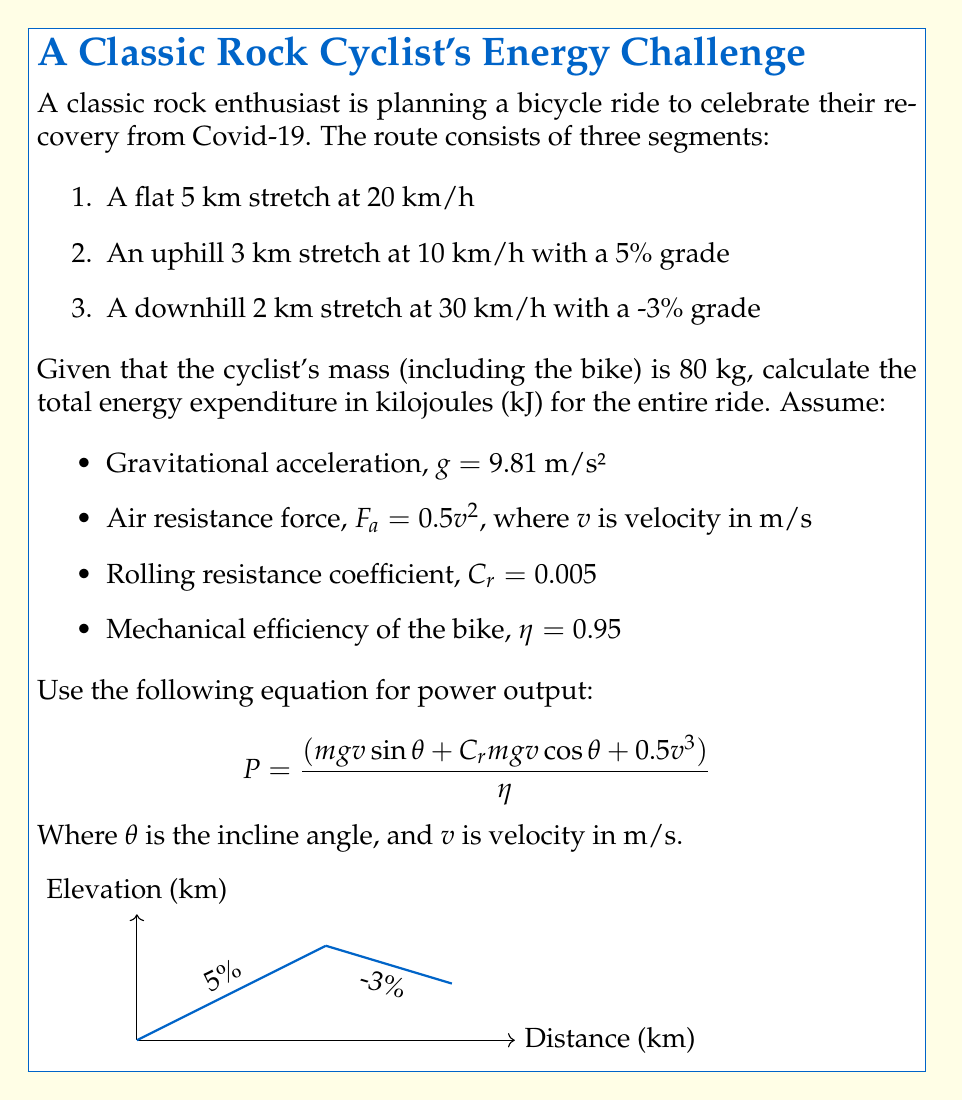Help me with this question. Let's break this down step-by-step:

1) First, we need to convert all speeds to m/s:
   20 km/h = 5.56 m/s
   10 km/h = 2.78 m/s
   30 km/h = 8.33 m/s

2) Calculate the incline angles:
   5% grade: $\theta_1 = \arctan(0.05) = 0.0499$ radians
   -3% grade: $\theta_2 = \arctan(-0.03) = -0.0300$ radians

3) Now, let's calculate the power for each segment using the given equation:

   Segment 1 (flat):
   $$P_1 = \frac{(80 \cdot 9.81 \cdot 5.56 \cdot \sin(0) + 0.005 \cdot 80 \cdot 9.81 \cdot 5.56 \cdot \cos(0) + 0.5 \cdot 5.56^3)}{0.95} = 156.8 \text{ W}$$

   Segment 2 (uphill):
   $$P_2 = \frac{(80 \cdot 9.81 \cdot 2.78 \cdot \sin(0.0499) + 0.005 \cdot 80 \cdot 9.81 \cdot 2.78 \cdot \cos(0.0499) + 0.5 \cdot 2.78^3)}{0.95} = 302.7 \text{ W}$$

   Segment 3 (downhill):
   $$P_3 = \frac{(80 \cdot 9.81 \cdot 8.33 \cdot \sin(-0.0300) + 0.005 \cdot 80 \cdot 9.81 \cdot 8.33 \cdot \cos(-0.0300) + 0.5 \cdot 8.33^3)}{0.95} = 131.1 \text{ W}$$

4) Calculate the time for each segment:
   Segment 1: $t_1 = 5000 \text{ m} / 5.56 \text{ m/s} = 900 \text{ s}$
   Segment 2: $t_2 = 3000 \text{ m} / 2.78 \text{ m/s} = 1080 \text{ s}$
   Segment 3: $t_3 = 2000 \text{ m} / 8.33 \text{ m/s} = 240 \text{ s}$

5) Calculate the energy expenditure for each segment:
   $E_1 = P_1 \cdot t_1 = 156.8 \text{ W} \cdot 900 \text{ s} = 141,120 \text{ J} = 141.1 \text{ kJ}$
   $E_2 = P_2 \cdot t_2 = 302.7 \text{ W} \cdot 1080 \text{ s} = 326,916 \text{ J} = 326.9 \text{ kJ}$
   $E_3 = P_3 \cdot t_3 = 131.1 \text{ W} \cdot 240 \text{ s} = 31,464 \text{ J} = 31.5 \text{ kJ}$

6) Sum up the total energy expenditure:
   $E_{total} = E_1 + E_2 + E_3 = 141.1 + 326.9 + 31.5 = 499.5 \text{ kJ}$
Answer: 499.5 kJ 